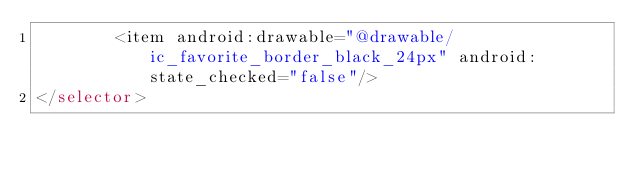Convert code to text. <code><loc_0><loc_0><loc_500><loc_500><_XML_>        <item android:drawable="@drawable/ic_favorite_border_black_24px" android:state_checked="false"/>
</selector></code> 